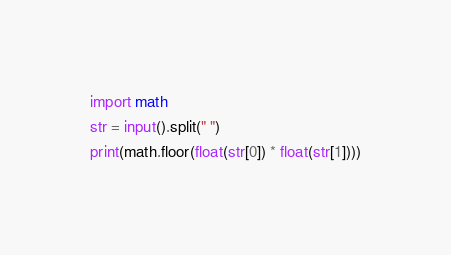Convert code to text. <code><loc_0><loc_0><loc_500><loc_500><_Cython_>import math
str = input().split(" ")
print(math.floor(float(str[0]) * float(str[1])))</code> 